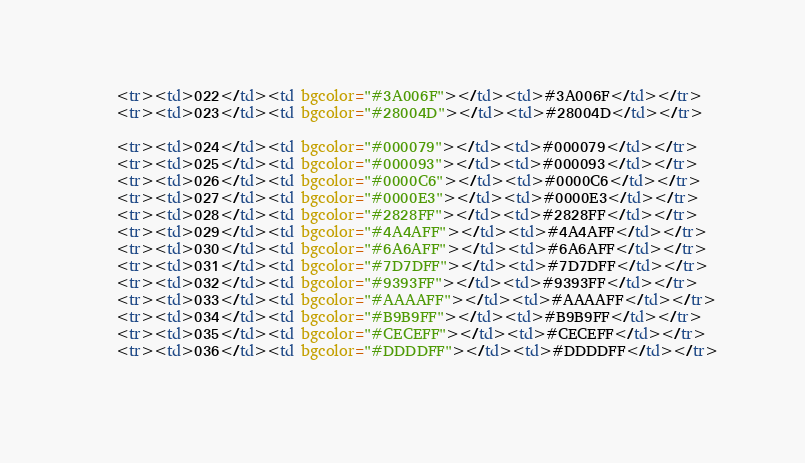Convert code to text. <code><loc_0><loc_0><loc_500><loc_500><_HTML_>    <tr><td>022</td><td bgcolor="#3A006F"></td><td>#3A006F</td></tr>
    <tr><td>023</td><td bgcolor="#28004D"></td><td>#28004D</td></tr>
    
    <tr><td>024</td><td bgcolor="#000079"></td><td>#000079</td></tr>
    <tr><td>025</td><td bgcolor="#000093"></td><td>#000093</td></tr>
    <tr><td>026</td><td bgcolor="#0000C6"></td><td>#0000C6</td></tr>
    <tr><td>027</td><td bgcolor="#0000E3"></td><td>#0000E3</td></tr>
    <tr><td>028</td><td bgcolor="#2828FF"></td><td>#2828FF</td></tr>
    <tr><td>029</td><td bgcolor="#4A4AFF"></td><td>#4A4AFF</td></tr>
    <tr><td>030</td><td bgcolor="#6A6AFF"></td><td>#6A6AFF</td></tr>
    <tr><td>031</td><td bgcolor="#7D7DFF"></td><td>#7D7DFF</td></tr>
    <tr><td>032</td><td bgcolor="#9393FF"></td><td>#9393FF</td></tr>
    <tr><td>033</td><td bgcolor="#AAAAFF"></td><td>#AAAAFF</td></tr>
    <tr><td>034</td><td bgcolor="#B9B9FF"></td><td>#B9B9FF</td></tr>
    <tr><td>035</td><td bgcolor="#CECEFF"></td><td>#CECEFF</td></tr>
    <tr><td>036</td><td bgcolor="#DDDDFF"></td><td>#DDDDFF</td></tr>
    </code> 